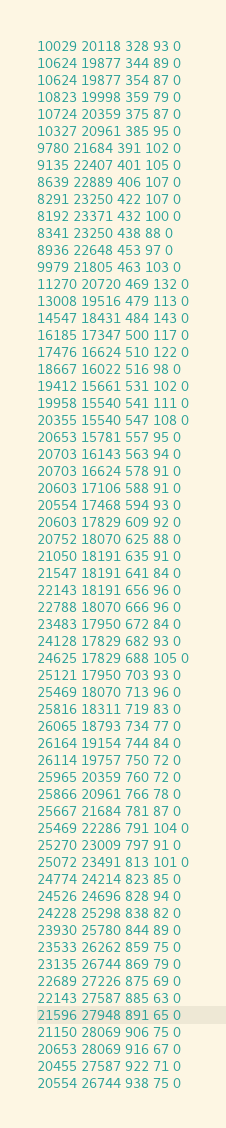<code> <loc_0><loc_0><loc_500><loc_500><_SML_>10029 20118 328 93 0
10624 19877 344 89 0
10624 19877 354 87 0
10823 19998 359 79 0
10724 20359 375 87 0
10327 20961 385 95 0
9780 21684 391 102 0
9135 22407 401 105 0
8639 22889 406 107 0
8291 23250 422 107 0
8192 23371 432 100 0
8341 23250 438 88 0
8936 22648 453 97 0
9979 21805 463 103 0
11270 20720 469 132 0
13008 19516 479 113 0
14547 18431 484 143 0
16185 17347 500 117 0
17476 16624 510 122 0
18667 16022 516 98 0
19412 15661 531 102 0
19958 15540 541 111 0
20355 15540 547 108 0
20653 15781 557 95 0
20703 16143 563 94 0
20703 16624 578 91 0
20603 17106 588 91 0
20554 17468 594 93 0
20603 17829 609 92 0
20752 18070 625 88 0
21050 18191 635 91 0
21547 18191 641 84 0
22143 18191 656 96 0
22788 18070 666 96 0
23483 17950 672 84 0
24128 17829 682 93 0
24625 17829 688 105 0
25121 17950 703 93 0
25469 18070 713 96 0
25816 18311 719 83 0
26065 18793 734 77 0
26164 19154 744 84 0
26114 19757 750 72 0
25965 20359 760 72 0
25866 20961 766 78 0
25667 21684 781 87 0
25469 22286 791 104 0
25270 23009 797 91 0
25072 23491 813 101 0
24774 24214 823 85 0
24526 24696 828 94 0
24228 25298 838 82 0
23930 25780 844 89 0
23533 26262 859 75 0
23135 26744 869 79 0
22689 27226 875 69 0
22143 27587 885 63 0
21596 27948 891 65 0
21150 28069 906 75 0
20653 28069 916 67 0
20455 27587 922 71 0
20554 26744 938 75 0</code> 